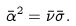Convert formula to latex. <formula><loc_0><loc_0><loc_500><loc_500>\bar { \alpha } ^ { 2 } = \bar { \nu } \bar { \sigma } .</formula> 